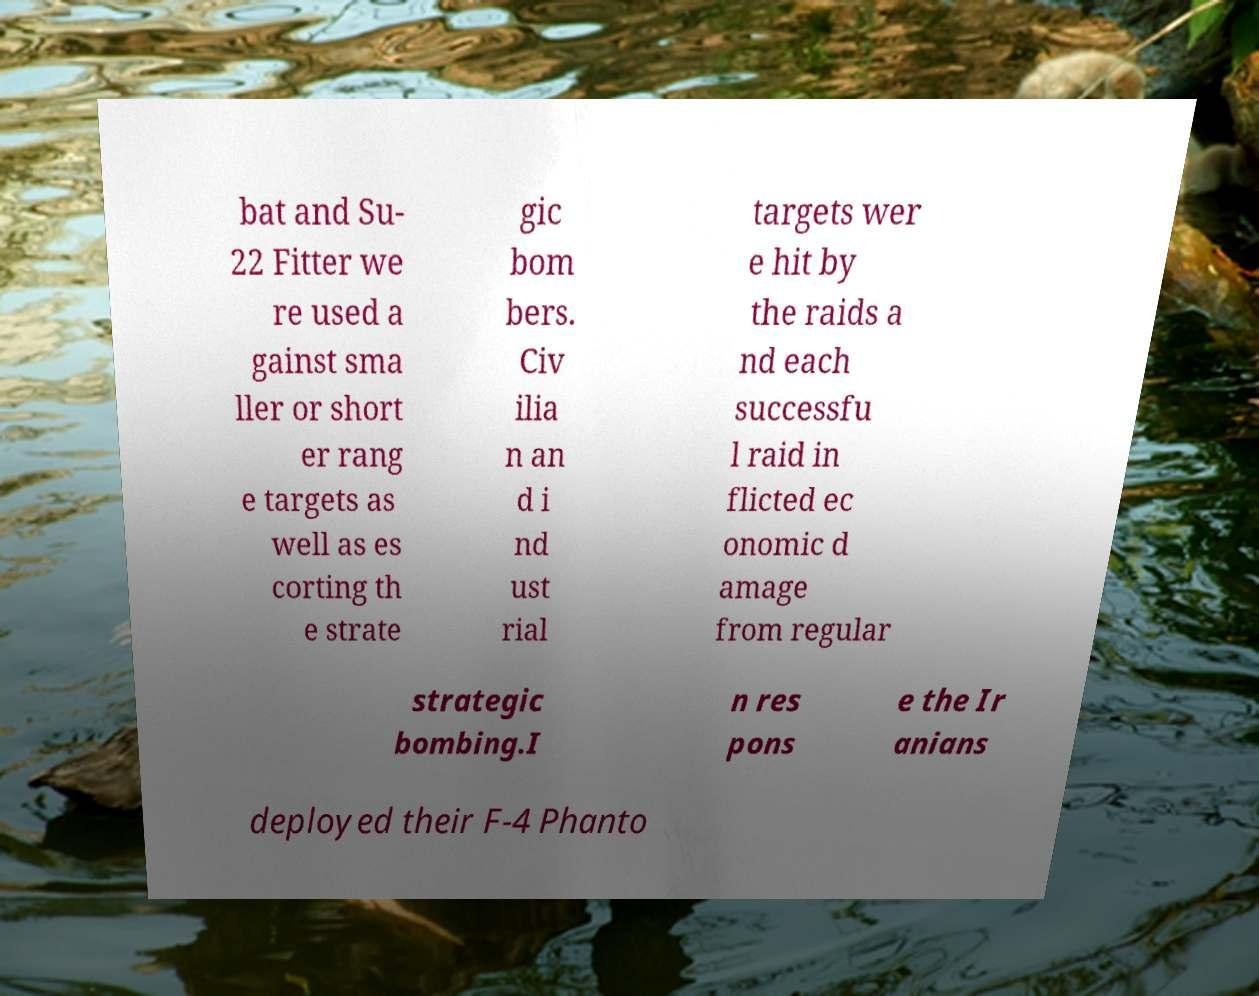For documentation purposes, I need the text within this image transcribed. Could you provide that? bat and Su- 22 Fitter we re used a gainst sma ller or short er rang e targets as well as es corting th e strate gic bom bers. Civ ilia n an d i nd ust rial targets wer e hit by the raids a nd each successfu l raid in flicted ec onomic d amage from regular strategic bombing.I n res pons e the Ir anians deployed their F-4 Phanto 